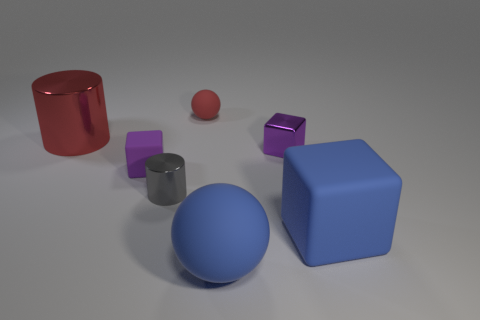Subtract all large blue rubber cubes. How many cubes are left? 2 Subtract all blue cubes. How many cubes are left? 2 Add 1 tiny rubber things. How many objects exist? 8 Subtract 1 balls. How many balls are left? 1 Add 6 small metallic cylinders. How many small metallic cylinders exist? 7 Subtract 0 purple spheres. How many objects are left? 7 Subtract all blocks. How many objects are left? 4 Subtract all purple blocks. Subtract all gray cylinders. How many blocks are left? 1 Subtract all brown cubes. How many yellow balls are left? 0 Subtract all large cyan matte spheres. Subtract all large red shiny things. How many objects are left? 6 